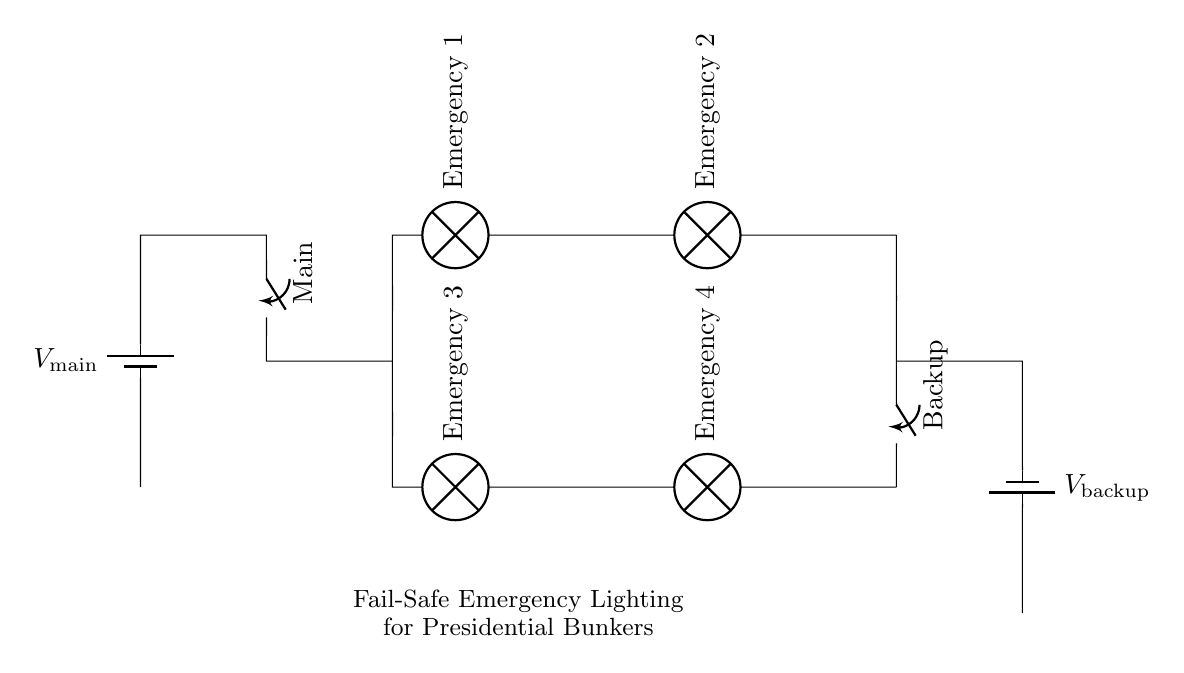What type of circuit is represented? The circuit is a parallel circuit, which can be identified by the layout where multiple branches connect to the same voltage sources.
Answer: Parallel How many emergency lights are present? There are four emergency lights depicted in the circuit diagram, two at the top branch and two at the bottom branch.
Answer: Four What are the names of the switches in the circuit? The switches are labeled as Main and Backup, indicating their respective roles in managing the circuit's power source.
Answer: Main, Backup What voltage is supplied by the main source? The main source voltage is denoted as V main, which is the input from the primary battery providing power to the circuit.
Answer: V main How does the backup function in this circuit? The backup system provides an alternative power source, allowing the emergency lights to remain operational if the main source fails. This functionality is achieved through the connection of the backup battery when the Main switch is OFF.
Answer: Alternative power source What happens if one emergency light fails? If one emergency light fails, the others will still function because they are connected in parallel, ensuring continuous operation of the remaining lights.
Answer: Continuous operation Which components are used for power supply? The components used for power supply are the two batteries labeled as V main and V backup, each providing voltage to the circuit.
Answer: V main, V backup 